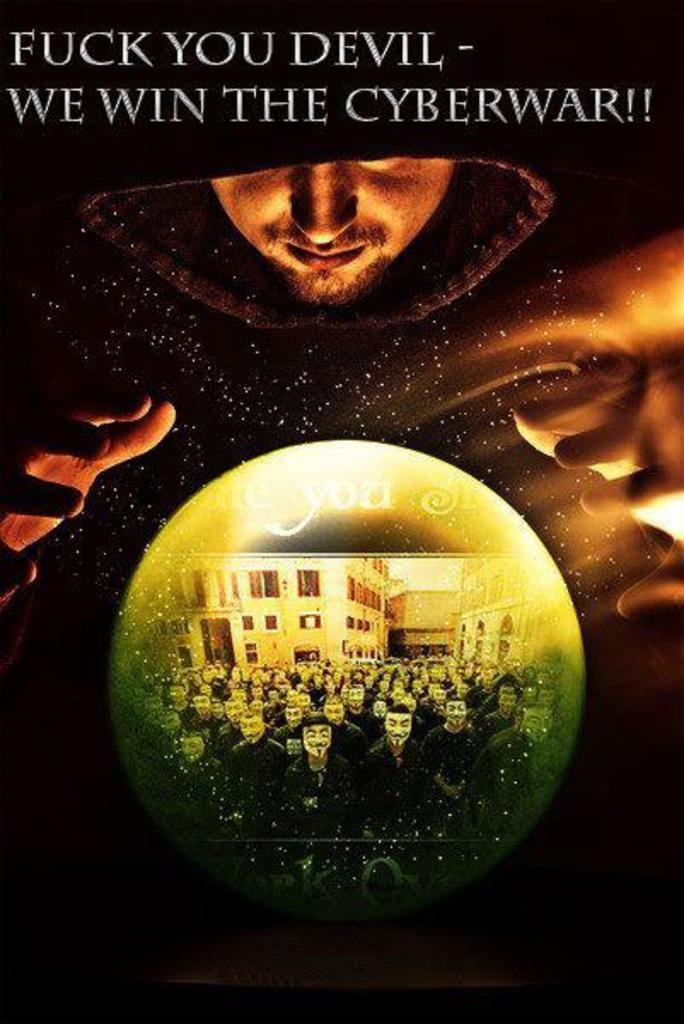Provide a one-sentence caption for the provided image. A person looking over a crystal ball that has a title that says We win the Cyberwar above the person. 